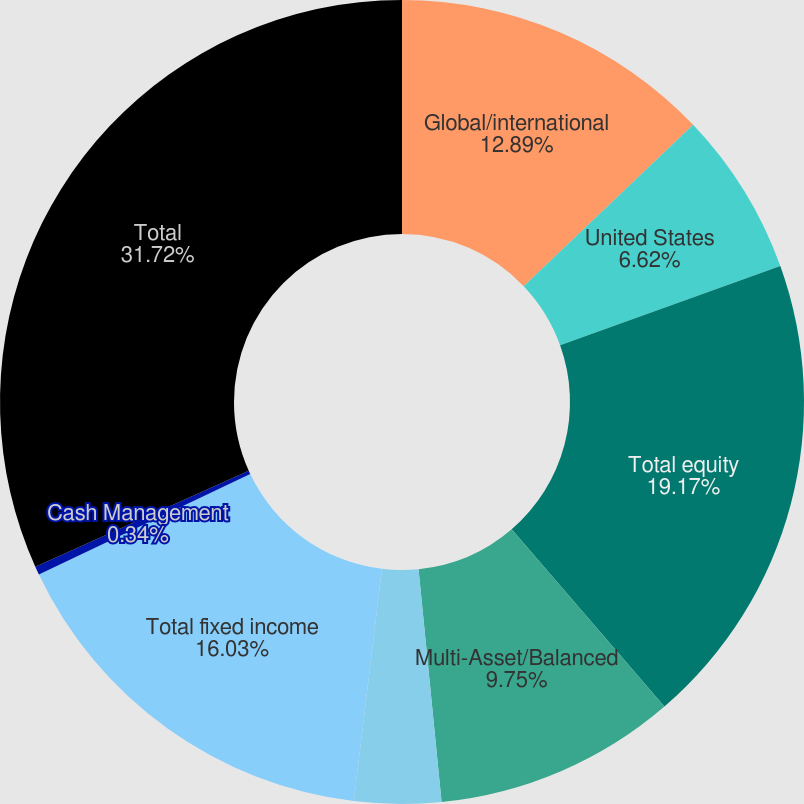Convert chart to OTSL. <chart><loc_0><loc_0><loc_500><loc_500><pie_chart><fcel>Global/international<fcel>United States<fcel>Total equity<fcel>Multi-Asset/Balanced<fcel>Tax-free<fcel>Total fixed income<fcel>Cash Management<fcel>Total<nl><fcel>12.89%<fcel>6.62%<fcel>19.17%<fcel>9.75%<fcel>3.48%<fcel>16.03%<fcel>0.34%<fcel>31.72%<nl></chart> 